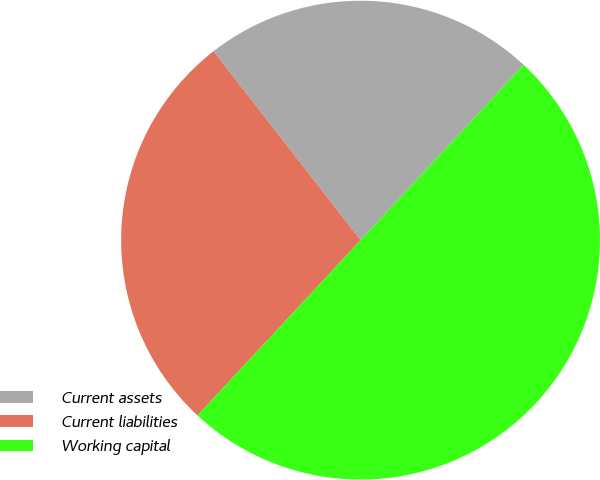Convert chart. <chart><loc_0><loc_0><loc_500><loc_500><pie_chart><fcel>Current assets<fcel>Current liabilities<fcel>Working capital<nl><fcel>22.45%<fcel>27.55%<fcel>50.0%<nl></chart> 